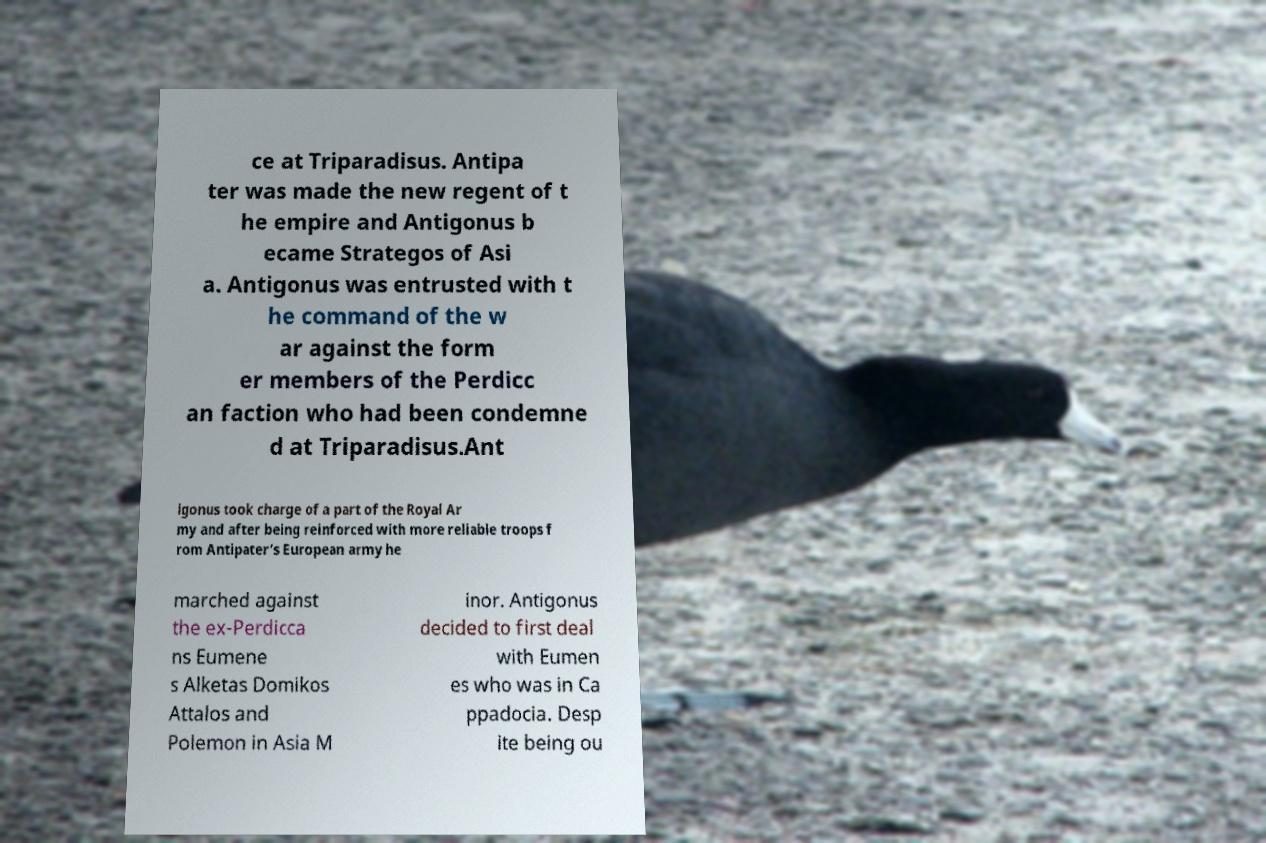For documentation purposes, I need the text within this image transcribed. Could you provide that? ce at Triparadisus. Antipa ter was made the new regent of t he empire and Antigonus b ecame Strategos of Asi a. Antigonus was entrusted with t he command of the w ar against the form er members of the Perdicc an faction who had been condemne d at Triparadisus.Ant igonus took charge of a part of the Royal Ar my and after being reinforced with more reliable troops f rom Antipater’s European army he marched against the ex-Perdicca ns Eumene s Alketas Domikos Attalos and Polemon in Asia M inor. Antigonus decided to first deal with Eumen es who was in Ca ppadocia. Desp ite being ou 